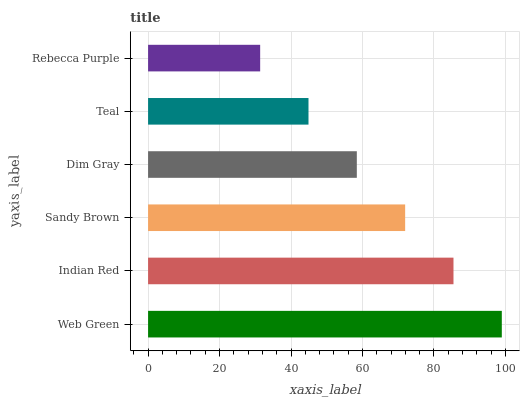Is Rebecca Purple the minimum?
Answer yes or no. Yes. Is Web Green the maximum?
Answer yes or no. Yes. Is Indian Red the minimum?
Answer yes or no. No. Is Indian Red the maximum?
Answer yes or no. No. Is Web Green greater than Indian Red?
Answer yes or no. Yes. Is Indian Red less than Web Green?
Answer yes or no. Yes. Is Indian Red greater than Web Green?
Answer yes or no. No. Is Web Green less than Indian Red?
Answer yes or no. No. Is Sandy Brown the high median?
Answer yes or no. Yes. Is Dim Gray the low median?
Answer yes or no. Yes. Is Rebecca Purple the high median?
Answer yes or no. No. Is Rebecca Purple the low median?
Answer yes or no. No. 